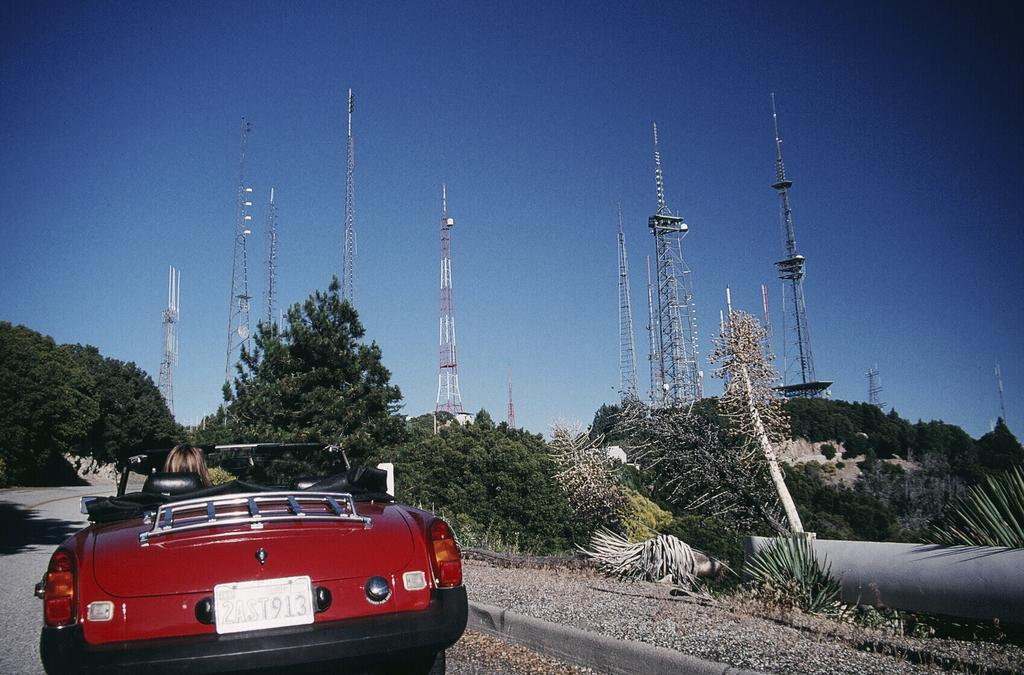What is the person in the image doing? There is a person sitting in a car in the image. Where is the car located? on the road? What can be seen in front of the car? There are trees and electric towers in front of the car in the image. What is visible in the sky in the image? The sky is visible in the image. What type of brass instrument is the person playing in the car? There is no brass instrument present in the image; the person is sitting in a car. 